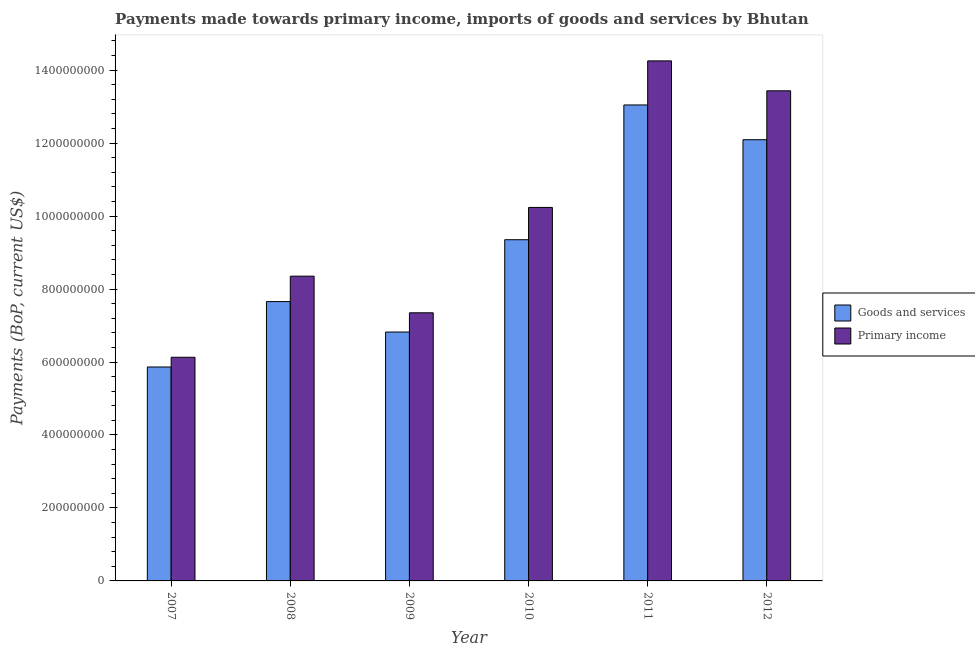How many different coloured bars are there?
Ensure brevity in your answer.  2. Are the number of bars per tick equal to the number of legend labels?
Make the answer very short. Yes. Are the number of bars on each tick of the X-axis equal?
Ensure brevity in your answer.  Yes. How many bars are there on the 3rd tick from the right?
Your response must be concise. 2. What is the label of the 3rd group of bars from the left?
Your answer should be very brief. 2009. In how many cases, is the number of bars for a given year not equal to the number of legend labels?
Make the answer very short. 0. What is the payments made towards goods and services in 2010?
Ensure brevity in your answer.  9.35e+08. Across all years, what is the maximum payments made towards primary income?
Your answer should be compact. 1.43e+09. Across all years, what is the minimum payments made towards goods and services?
Provide a short and direct response. 5.86e+08. In which year was the payments made towards goods and services maximum?
Offer a terse response. 2011. In which year was the payments made towards primary income minimum?
Your answer should be compact. 2007. What is the total payments made towards goods and services in the graph?
Your answer should be very brief. 5.48e+09. What is the difference between the payments made towards goods and services in 2009 and that in 2012?
Provide a succinct answer. -5.27e+08. What is the difference between the payments made towards primary income in 2009 and the payments made towards goods and services in 2012?
Keep it short and to the point. -6.08e+08. What is the average payments made towards primary income per year?
Your answer should be compact. 9.96e+08. What is the ratio of the payments made towards goods and services in 2010 to that in 2012?
Ensure brevity in your answer.  0.77. Is the payments made towards primary income in 2007 less than that in 2009?
Your answer should be compact. Yes. What is the difference between the highest and the second highest payments made towards primary income?
Ensure brevity in your answer.  8.20e+07. What is the difference between the highest and the lowest payments made towards goods and services?
Keep it short and to the point. 7.18e+08. Is the sum of the payments made towards goods and services in 2008 and 2012 greater than the maximum payments made towards primary income across all years?
Offer a very short reply. Yes. What does the 2nd bar from the left in 2010 represents?
Your answer should be very brief. Primary income. What does the 1st bar from the right in 2009 represents?
Keep it short and to the point. Primary income. Are the values on the major ticks of Y-axis written in scientific E-notation?
Your answer should be very brief. No. Does the graph contain any zero values?
Your answer should be very brief. No. Does the graph contain grids?
Offer a terse response. No. Where does the legend appear in the graph?
Your response must be concise. Center right. How many legend labels are there?
Offer a terse response. 2. How are the legend labels stacked?
Offer a terse response. Vertical. What is the title of the graph?
Provide a succinct answer. Payments made towards primary income, imports of goods and services by Bhutan. Does "Canada" appear as one of the legend labels in the graph?
Provide a short and direct response. No. What is the label or title of the X-axis?
Offer a terse response. Year. What is the label or title of the Y-axis?
Provide a succinct answer. Payments (BoP, current US$). What is the Payments (BoP, current US$) in Goods and services in 2007?
Keep it short and to the point. 5.86e+08. What is the Payments (BoP, current US$) in Primary income in 2007?
Make the answer very short. 6.13e+08. What is the Payments (BoP, current US$) in Goods and services in 2008?
Give a very brief answer. 7.66e+08. What is the Payments (BoP, current US$) of Primary income in 2008?
Your response must be concise. 8.35e+08. What is the Payments (BoP, current US$) of Goods and services in 2009?
Provide a succinct answer. 6.82e+08. What is the Payments (BoP, current US$) of Primary income in 2009?
Your response must be concise. 7.35e+08. What is the Payments (BoP, current US$) of Goods and services in 2010?
Your answer should be very brief. 9.35e+08. What is the Payments (BoP, current US$) of Primary income in 2010?
Your answer should be very brief. 1.02e+09. What is the Payments (BoP, current US$) in Goods and services in 2011?
Offer a terse response. 1.30e+09. What is the Payments (BoP, current US$) of Primary income in 2011?
Keep it short and to the point. 1.43e+09. What is the Payments (BoP, current US$) of Goods and services in 2012?
Ensure brevity in your answer.  1.21e+09. What is the Payments (BoP, current US$) in Primary income in 2012?
Offer a terse response. 1.34e+09. Across all years, what is the maximum Payments (BoP, current US$) of Goods and services?
Your answer should be very brief. 1.30e+09. Across all years, what is the maximum Payments (BoP, current US$) of Primary income?
Offer a very short reply. 1.43e+09. Across all years, what is the minimum Payments (BoP, current US$) in Goods and services?
Your answer should be compact. 5.86e+08. Across all years, what is the minimum Payments (BoP, current US$) in Primary income?
Make the answer very short. 6.13e+08. What is the total Payments (BoP, current US$) of Goods and services in the graph?
Ensure brevity in your answer.  5.48e+09. What is the total Payments (BoP, current US$) in Primary income in the graph?
Provide a short and direct response. 5.98e+09. What is the difference between the Payments (BoP, current US$) of Goods and services in 2007 and that in 2008?
Provide a short and direct response. -1.79e+08. What is the difference between the Payments (BoP, current US$) of Primary income in 2007 and that in 2008?
Your answer should be compact. -2.22e+08. What is the difference between the Payments (BoP, current US$) of Goods and services in 2007 and that in 2009?
Your response must be concise. -9.58e+07. What is the difference between the Payments (BoP, current US$) of Primary income in 2007 and that in 2009?
Keep it short and to the point. -1.22e+08. What is the difference between the Payments (BoP, current US$) in Goods and services in 2007 and that in 2010?
Your answer should be very brief. -3.49e+08. What is the difference between the Payments (BoP, current US$) of Primary income in 2007 and that in 2010?
Ensure brevity in your answer.  -4.11e+08. What is the difference between the Payments (BoP, current US$) in Goods and services in 2007 and that in 2011?
Provide a succinct answer. -7.18e+08. What is the difference between the Payments (BoP, current US$) in Primary income in 2007 and that in 2011?
Ensure brevity in your answer.  -8.12e+08. What is the difference between the Payments (BoP, current US$) of Goods and services in 2007 and that in 2012?
Your response must be concise. -6.23e+08. What is the difference between the Payments (BoP, current US$) of Primary income in 2007 and that in 2012?
Your response must be concise. -7.30e+08. What is the difference between the Payments (BoP, current US$) of Goods and services in 2008 and that in 2009?
Offer a terse response. 8.35e+07. What is the difference between the Payments (BoP, current US$) of Primary income in 2008 and that in 2009?
Your answer should be very brief. 1.00e+08. What is the difference between the Payments (BoP, current US$) of Goods and services in 2008 and that in 2010?
Your response must be concise. -1.70e+08. What is the difference between the Payments (BoP, current US$) in Primary income in 2008 and that in 2010?
Provide a succinct answer. -1.88e+08. What is the difference between the Payments (BoP, current US$) of Goods and services in 2008 and that in 2011?
Ensure brevity in your answer.  -5.39e+08. What is the difference between the Payments (BoP, current US$) in Primary income in 2008 and that in 2011?
Provide a succinct answer. -5.90e+08. What is the difference between the Payments (BoP, current US$) of Goods and services in 2008 and that in 2012?
Provide a short and direct response. -4.44e+08. What is the difference between the Payments (BoP, current US$) of Primary income in 2008 and that in 2012?
Offer a very short reply. -5.08e+08. What is the difference between the Payments (BoP, current US$) in Goods and services in 2009 and that in 2010?
Give a very brief answer. -2.53e+08. What is the difference between the Payments (BoP, current US$) in Primary income in 2009 and that in 2010?
Your answer should be very brief. -2.89e+08. What is the difference between the Payments (BoP, current US$) of Goods and services in 2009 and that in 2011?
Your response must be concise. -6.22e+08. What is the difference between the Payments (BoP, current US$) in Primary income in 2009 and that in 2011?
Your response must be concise. -6.90e+08. What is the difference between the Payments (BoP, current US$) of Goods and services in 2009 and that in 2012?
Offer a very short reply. -5.27e+08. What is the difference between the Payments (BoP, current US$) of Primary income in 2009 and that in 2012?
Provide a succinct answer. -6.08e+08. What is the difference between the Payments (BoP, current US$) of Goods and services in 2010 and that in 2011?
Offer a very short reply. -3.69e+08. What is the difference between the Payments (BoP, current US$) of Primary income in 2010 and that in 2011?
Make the answer very short. -4.02e+08. What is the difference between the Payments (BoP, current US$) in Goods and services in 2010 and that in 2012?
Make the answer very short. -2.74e+08. What is the difference between the Payments (BoP, current US$) of Primary income in 2010 and that in 2012?
Provide a short and direct response. -3.20e+08. What is the difference between the Payments (BoP, current US$) in Goods and services in 2011 and that in 2012?
Provide a short and direct response. 9.52e+07. What is the difference between the Payments (BoP, current US$) of Primary income in 2011 and that in 2012?
Offer a very short reply. 8.20e+07. What is the difference between the Payments (BoP, current US$) in Goods and services in 2007 and the Payments (BoP, current US$) in Primary income in 2008?
Provide a succinct answer. -2.49e+08. What is the difference between the Payments (BoP, current US$) of Goods and services in 2007 and the Payments (BoP, current US$) of Primary income in 2009?
Your answer should be very brief. -1.49e+08. What is the difference between the Payments (BoP, current US$) in Goods and services in 2007 and the Payments (BoP, current US$) in Primary income in 2010?
Give a very brief answer. -4.37e+08. What is the difference between the Payments (BoP, current US$) of Goods and services in 2007 and the Payments (BoP, current US$) of Primary income in 2011?
Offer a terse response. -8.39e+08. What is the difference between the Payments (BoP, current US$) in Goods and services in 2007 and the Payments (BoP, current US$) in Primary income in 2012?
Your response must be concise. -7.57e+08. What is the difference between the Payments (BoP, current US$) of Goods and services in 2008 and the Payments (BoP, current US$) of Primary income in 2009?
Provide a short and direct response. 3.07e+07. What is the difference between the Payments (BoP, current US$) in Goods and services in 2008 and the Payments (BoP, current US$) in Primary income in 2010?
Provide a succinct answer. -2.58e+08. What is the difference between the Payments (BoP, current US$) in Goods and services in 2008 and the Payments (BoP, current US$) in Primary income in 2011?
Offer a terse response. -6.60e+08. What is the difference between the Payments (BoP, current US$) of Goods and services in 2008 and the Payments (BoP, current US$) of Primary income in 2012?
Ensure brevity in your answer.  -5.78e+08. What is the difference between the Payments (BoP, current US$) in Goods and services in 2009 and the Payments (BoP, current US$) in Primary income in 2010?
Give a very brief answer. -3.42e+08. What is the difference between the Payments (BoP, current US$) in Goods and services in 2009 and the Payments (BoP, current US$) in Primary income in 2011?
Your answer should be very brief. -7.43e+08. What is the difference between the Payments (BoP, current US$) of Goods and services in 2009 and the Payments (BoP, current US$) of Primary income in 2012?
Provide a short and direct response. -6.61e+08. What is the difference between the Payments (BoP, current US$) in Goods and services in 2010 and the Payments (BoP, current US$) in Primary income in 2011?
Provide a short and direct response. -4.90e+08. What is the difference between the Payments (BoP, current US$) of Goods and services in 2010 and the Payments (BoP, current US$) of Primary income in 2012?
Provide a succinct answer. -4.08e+08. What is the difference between the Payments (BoP, current US$) in Goods and services in 2011 and the Payments (BoP, current US$) in Primary income in 2012?
Keep it short and to the point. -3.88e+07. What is the average Payments (BoP, current US$) in Goods and services per year?
Offer a terse response. 9.14e+08. What is the average Payments (BoP, current US$) in Primary income per year?
Keep it short and to the point. 9.96e+08. In the year 2007, what is the difference between the Payments (BoP, current US$) of Goods and services and Payments (BoP, current US$) of Primary income?
Your response must be concise. -2.67e+07. In the year 2008, what is the difference between the Payments (BoP, current US$) in Goods and services and Payments (BoP, current US$) in Primary income?
Your answer should be compact. -6.97e+07. In the year 2009, what is the difference between the Payments (BoP, current US$) of Goods and services and Payments (BoP, current US$) of Primary income?
Ensure brevity in your answer.  -5.27e+07. In the year 2010, what is the difference between the Payments (BoP, current US$) in Goods and services and Payments (BoP, current US$) in Primary income?
Give a very brief answer. -8.85e+07. In the year 2011, what is the difference between the Payments (BoP, current US$) in Goods and services and Payments (BoP, current US$) in Primary income?
Make the answer very short. -1.21e+08. In the year 2012, what is the difference between the Payments (BoP, current US$) in Goods and services and Payments (BoP, current US$) in Primary income?
Keep it short and to the point. -1.34e+08. What is the ratio of the Payments (BoP, current US$) of Goods and services in 2007 to that in 2008?
Provide a short and direct response. 0.77. What is the ratio of the Payments (BoP, current US$) of Primary income in 2007 to that in 2008?
Make the answer very short. 0.73. What is the ratio of the Payments (BoP, current US$) in Goods and services in 2007 to that in 2009?
Your answer should be very brief. 0.86. What is the ratio of the Payments (BoP, current US$) of Primary income in 2007 to that in 2009?
Make the answer very short. 0.83. What is the ratio of the Payments (BoP, current US$) of Goods and services in 2007 to that in 2010?
Offer a terse response. 0.63. What is the ratio of the Payments (BoP, current US$) in Primary income in 2007 to that in 2010?
Make the answer very short. 0.6. What is the ratio of the Payments (BoP, current US$) of Goods and services in 2007 to that in 2011?
Provide a short and direct response. 0.45. What is the ratio of the Payments (BoP, current US$) of Primary income in 2007 to that in 2011?
Your answer should be compact. 0.43. What is the ratio of the Payments (BoP, current US$) in Goods and services in 2007 to that in 2012?
Your response must be concise. 0.48. What is the ratio of the Payments (BoP, current US$) in Primary income in 2007 to that in 2012?
Make the answer very short. 0.46. What is the ratio of the Payments (BoP, current US$) in Goods and services in 2008 to that in 2009?
Offer a terse response. 1.12. What is the ratio of the Payments (BoP, current US$) of Primary income in 2008 to that in 2009?
Make the answer very short. 1.14. What is the ratio of the Payments (BoP, current US$) of Goods and services in 2008 to that in 2010?
Your answer should be very brief. 0.82. What is the ratio of the Payments (BoP, current US$) of Primary income in 2008 to that in 2010?
Make the answer very short. 0.82. What is the ratio of the Payments (BoP, current US$) in Goods and services in 2008 to that in 2011?
Your answer should be compact. 0.59. What is the ratio of the Payments (BoP, current US$) in Primary income in 2008 to that in 2011?
Make the answer very short. 0.59. What is the ratio of the Payments (BoP, current US$) of Goods and services in 2008 to that in 2012?
Your answer should be compact. 0.63. What is the ratio of the Payments (BoP, current US$) in Primary income in 2008 to that in 2012?
Provide a short and direct response. 0.62. What is the ratio of the Payments (BoP, current US$) in Goods and services in 2009 to that in 2010?
Offer a very short reply. 0.73. What is the ratio of the Payments (BoP, current US$) in Primary income in 2009 to that in 2010?
Give a very brief answer. 0.72. What is the ratio of the Payments (BoP, current US$) in Goods and services in 2009 to that in 2011?
Offer a terse response. 0.52. What is the ratio of the Payments (BoP, current US$) of Primary income in 2009 to that in 2011?
Keep it short and to the point. 0.52. What is the ratio of the Payments (BoP, current US$) in Goods and services in 2009 to that in 2012?
Your answer should be compact. 0.56. What is the ratio of the Payments (BoP, current US$) in Primary income in 2009 to that in 2012?
Provide a short and direct response. 0.55. What is the ratio of the Payments (BoP, current US$) of Goods and services in 2010 to that in 2011?
Offer a terse response. 0.72. What is the ratio of the Payments (BoP, current US$) in Primary income in 2010 to that in 2011?
Your answer should be very brief. 0.72. What is the ratio of the Payments (BoP, current US$) of Goods and services in 2010 to that in 2012?
Ensure brevity in your answer.  0.77. What is the ratio of the Payments (BoP, current US$) of Primary income in 2010 to that in 2012?
Your answer should be compact. 0.76. What is the ratio of the Payments (BoP, current US$) in Goods and services in 2011 to that in 2012?
Offer a terse response. 1.08. What is the ratio of the Payments (BoP, current US$) of Primary income in 2011 to that in 2012?
Your answer should be very brief. 1.06. What is the difference between the highest and the second highest Payments (BoP, current US$) in Goods and services?
Your answer should be very brief. 9.52e+07. What is the difference between the highest and the second highest Payments (BoP, current US$) of Primary income?
Keep it short and to the point. 8.20e+07. What is the difference between the highest and the lowest Payments (BoP, current US$) of Goods and services?
Your response must be concise. 7.18e+08. What is the difference between the highest and the lowest Payments (BoP, current US$) in Primary income?
Keep it short and to the point. 8.12e+08. 